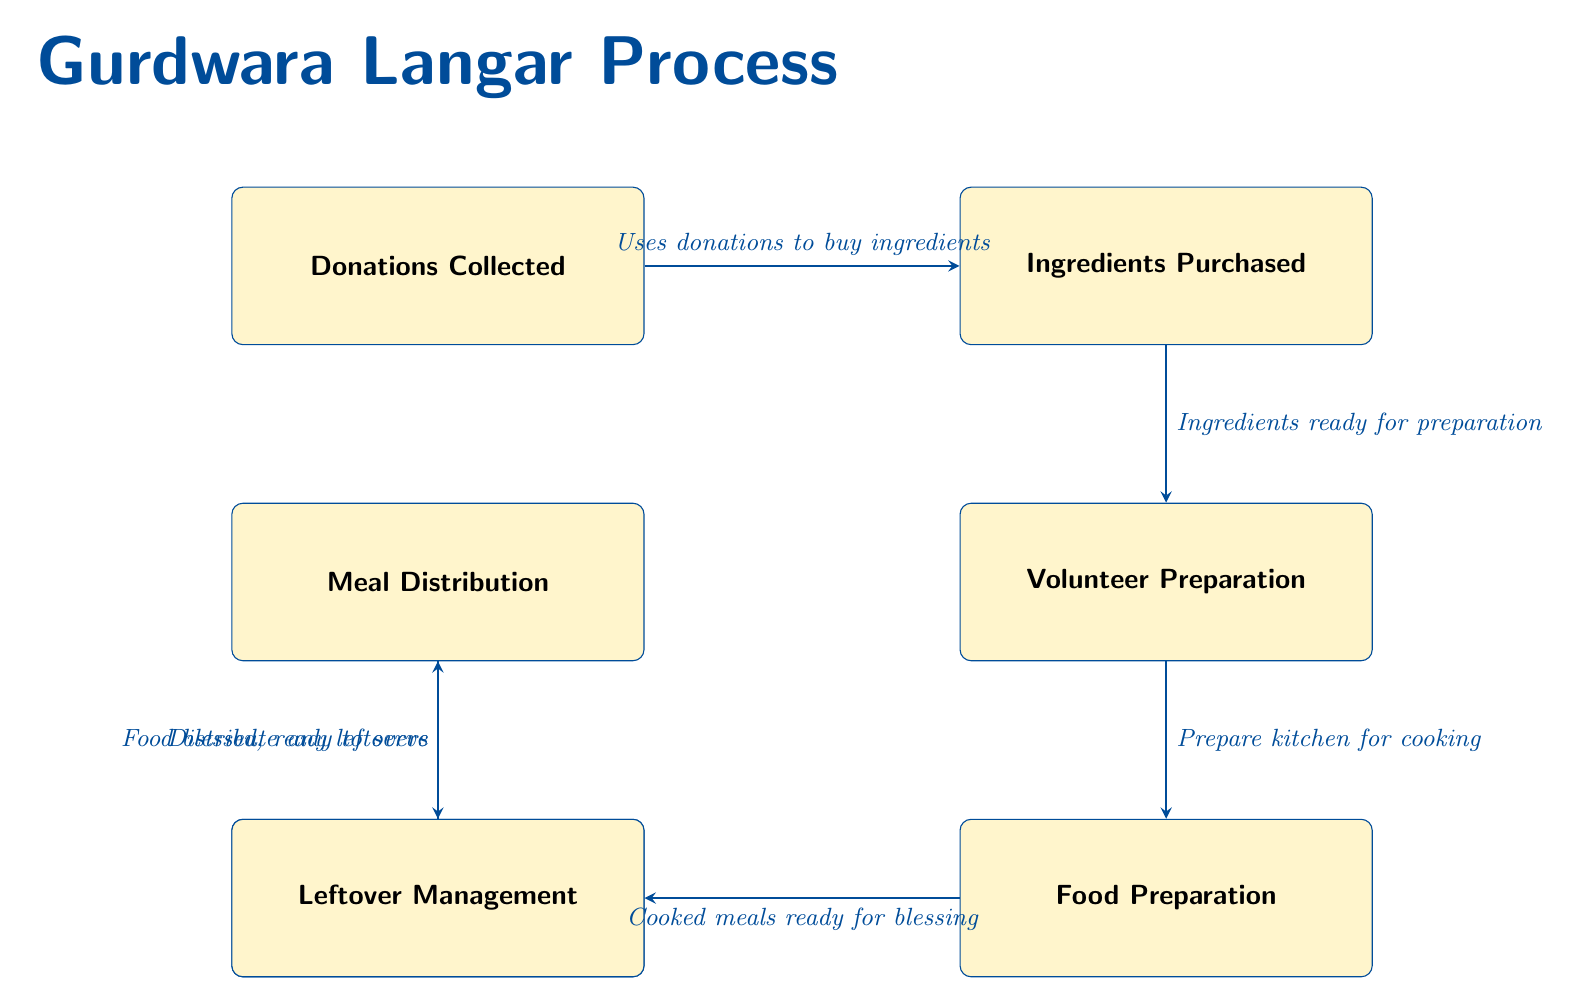What is the first step in the Gurdwara Langar process? The diagram indicates that the first step is "Donations Collected," which initiates the entire process.
Answer: Donations Collected What facilitates the purchase of ingredients? According to the diagram, the arrow from "Donations Collected" to "Ingredients Purchased" labels this relationship with "Uses donations to buy ingredients," indicating that collected donations facilitate the purchase.
Answer: Uses donations to buy ingredients What comes after Volunteer Preparation? The flow of the diagram shows that the step after "Volunteer Preparation" is "Food Preparation," indicating the sequential nature of these steps in the process.
Answer: Food Preparation How many steps are there before Meal Distribution? By counting the steps, we move from "Donations Collected" to "Ingredients Purchased," then to "Volunteer Preparation," and "Food Preparation," leading to "Prayers and Blessings" before arriving at "Meal Distribution." This totals five steps.
Answer: Five steps What is done with the leftovers after distribution? The diagram shows an arrow leading from "Meal Distribution" to "Leftover Management," indicating that the leftovers are managed after the meal has been distributed.
Answer: Distribute any leftovers What is included in the preparation before cooking? The relationship from "Volunteer Preparation" to "Food Preparation" in the diagram states "Prepare kitchen for cooking," which clarifies the preparatory actions needed before the actual cooking begins.
Answer: Prepare kitchen for cooking Which step directly follows the cooking of meals? The diagram indicates that after "Food Preparation," the next step in the process is "Prayers and Blessings," showing a direct succession of activities.
Answer: Prayers and Blessings Why is "Prayers and Blessings" an important step? The position of this step is crucial as it expresses the spiritual significance of the meal preparation process; it serves as a moment to seek blessings for the food before it is served.
Answer: Spiritual significance What connects Meal Distribution and Leftover Management? There is an arrow from "Meal Distribution" to "Leftover Management," representing the dependency where leftovers are addressed after the meal is served.
Answer: Distribute any leftovers 